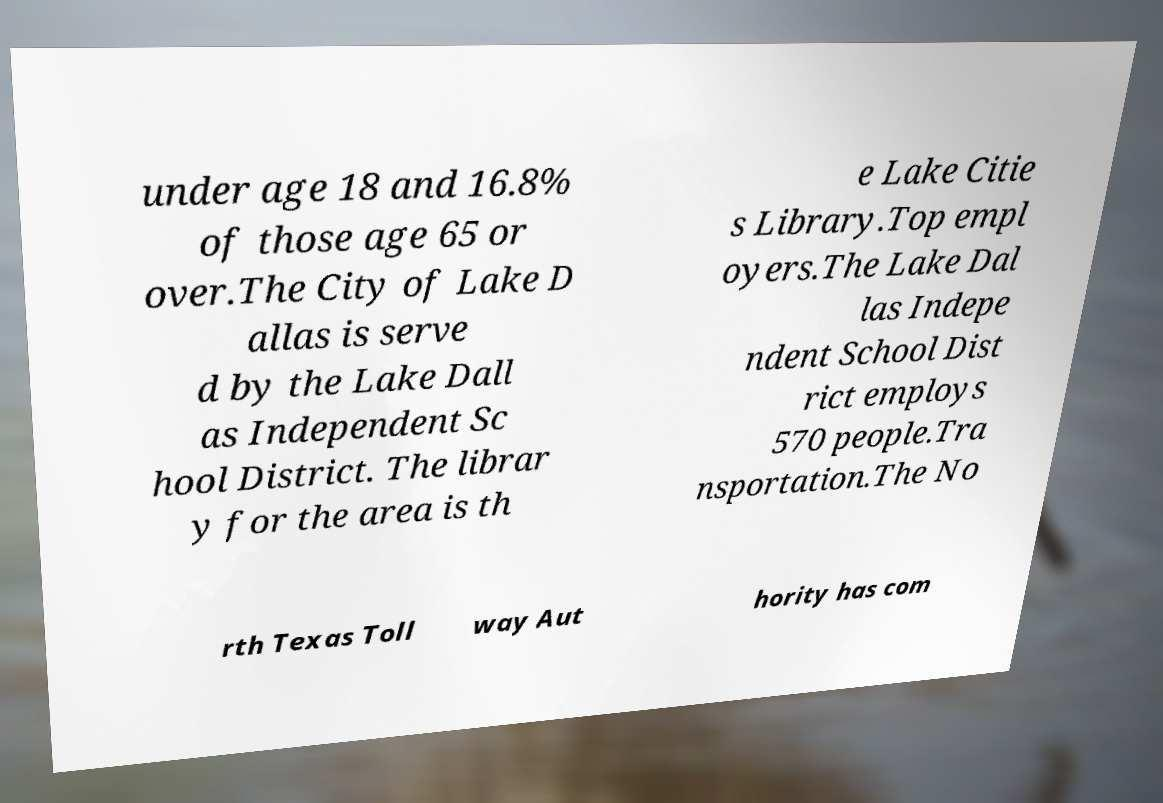Can you read and provide the text displayed in the image?This photo seems to have some interesting text. Can you extract and type it out for me? under age 18 and 16.8% of those age 65 or over.The City of Lake D allas is serve d by the Lake Dall as Independent Sc hool District. The librar y for the area is th e Lake Citie s Library.Top empl oyers.The Lake Dal las Indepe ndent School Dist rict employs 570 people.Tra nsportation.The No rth Texas Toll way Aut hority has com 